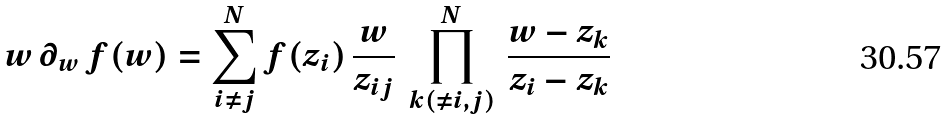Convert formula to latex. <formula><loc_0><loc_0><loc_500><loc_500>w \, \partial _ { w } \, f ( w ) = \sum _ { i \neq j } ^ { N } f ( z _ { i } ) \, \frac { w } { z _ { i j } } \, \prod _ { k ( \neq i , j ) } ^ { N } \, \frac { w - z _ { k } } { z _ { i } - z _ { k } }</formula> 